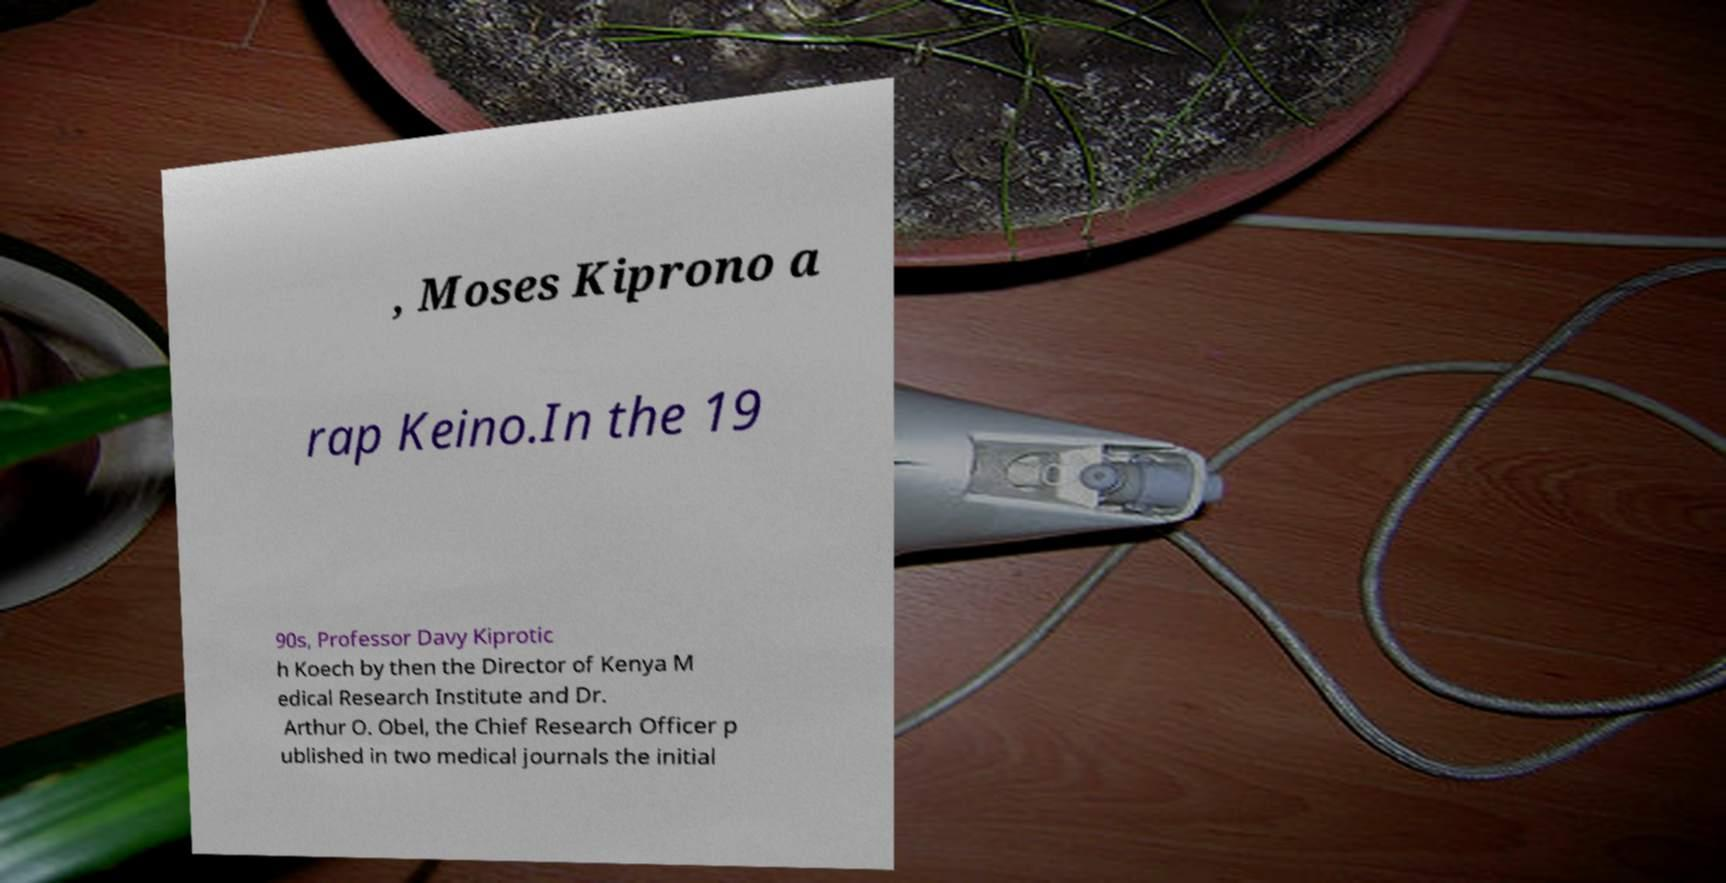I need the written content from this picture converted into text. Can you do that? , Moses Kiprono a rap Keino.In the 19 90s, Professor Davy Kiprotic h Koech by then the Director of Kenya M edical Research Institute and Dr. Arthur O. Obel, the Chief Research Officer p ublished in two medical journals the initial 